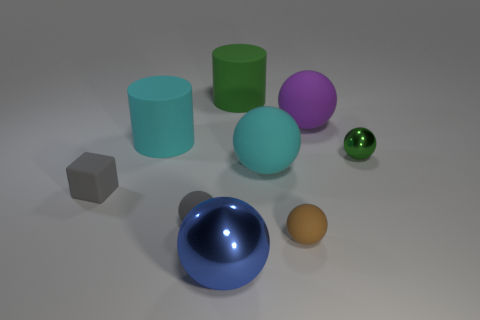What shape is the tiny object that is both to the right of the large blue metallic object and on the left side of the purple rubber object?
Offer a terse response. Sphere. What color is the large matte cylinder that is behind the purple sphere?
Provide a succinct answer. Green. There is a sphere that is behind the big metal object and in front of the small gray sphere; how big is it?
Your response must be concise. Small. Do the large blue object and the big cyan object that is to the right of the large blue shiny object have the same material?
Your answer should be very brief. No. What number of gray things are the same shape as the small green thing?
Keep it short and to the point. 1. There is a thing that is the same color as the small shiny sphere; what is it made of?
Your answer should be compact. Rubber. What number of objects are there?
Provide a succinct answer. 9. Is the shape of the brown thing the same as the large rubber thing left of the green cylinder?
Make the answer very short. No. How many things are big purple balls or balls behind the large blue metallic ball?
Offer a very short reply. 5. There is another green object that is the same shape as the large shiny thing; what is it made of?
Ensure brevity in your answer.  Metal. 